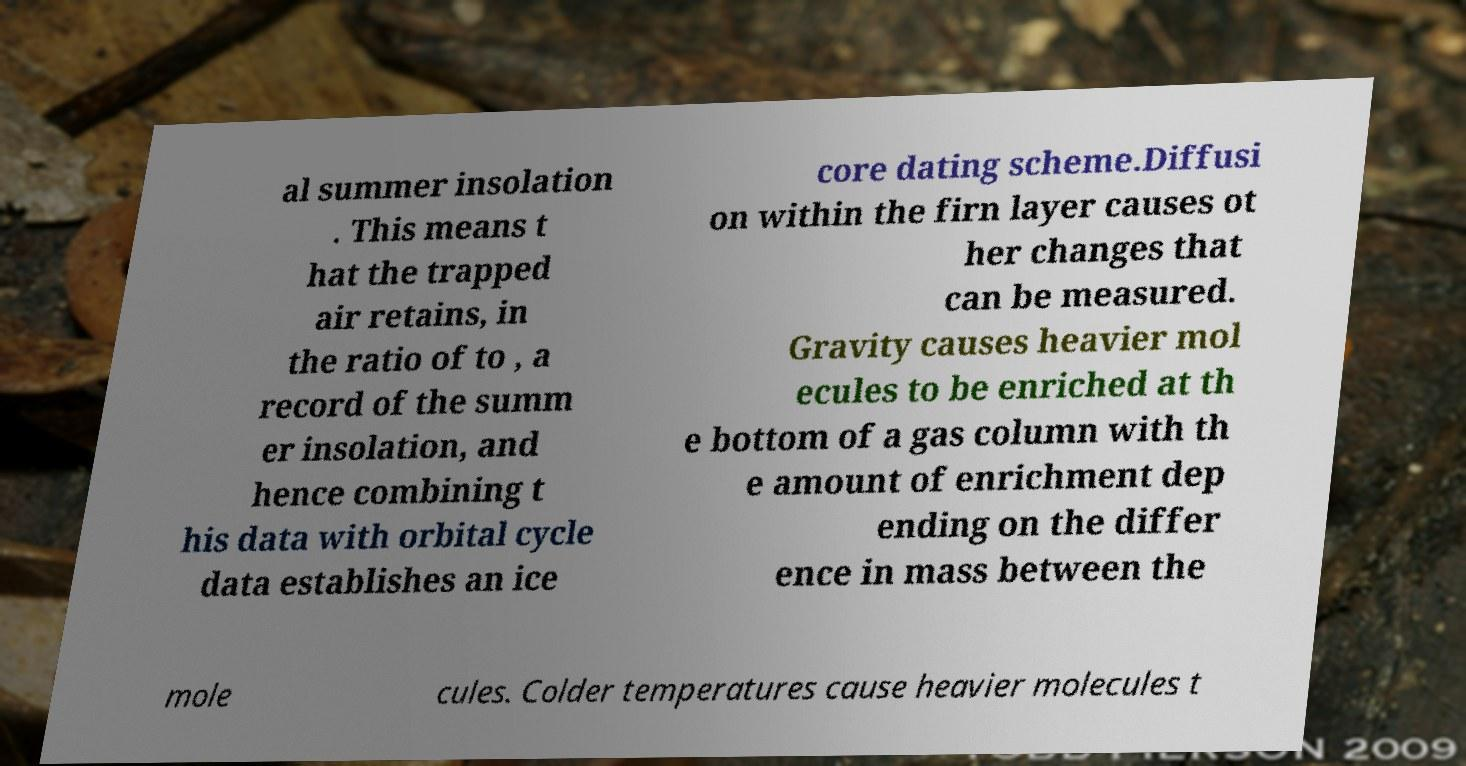Please identify and transcribe the text found in this image. al summer insolation . This means t hat the trapped air retains, in the ratio of to , a record of the summ er insolation, and hence combining t his data with orbital cycle data establishes an ice core dating scheme.Diffusi on within the firn layer causes ot her changes that can be measured. Gravity causes heavier mol ecules to be enriched at th e bottom of a gas column with th e amount of enrichment dep ending on the differ ence in mass between the mole cules. Colder temperatures cause heavier molecules t 